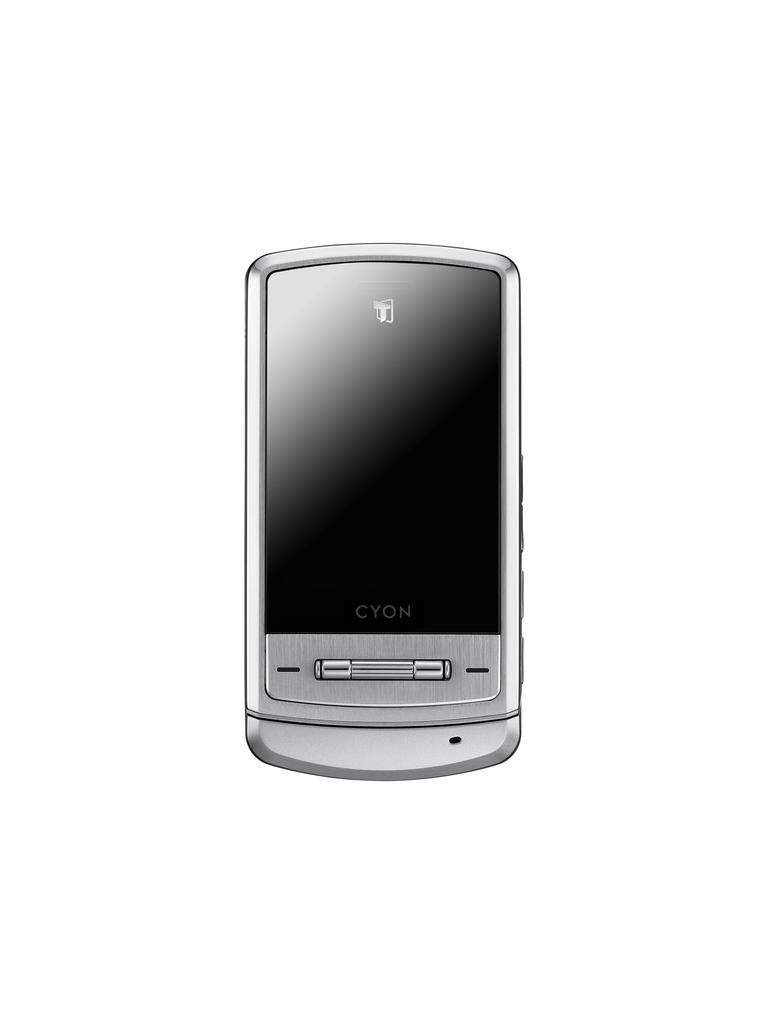<image>
Summarize the visual content of the image. a CYON silver cell phone displayed on a white background 